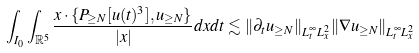Convert formula to latex. <formula><loc_0><loc_0><loc_500><loc_500>\int _ { I _ { 0 } } \int _ { \mathbb { R } ^ { 5 } } \frac { x \cdot \{ P _ { \geq N } [ u ( t ) ^ { 3 } ] , u _ { \geq N } \} } { | x | } d x d t & \lesssim \| \partial _ { t } u _ { \geq N } \| _ { L _ { t } ^ { \infty } L _ { x } ^ { 2 } } \| \nabla u _ { \geq N } \| _ { L _ { t } ^ { \infty } L _ { x } ^ { 2 } }</formula> 